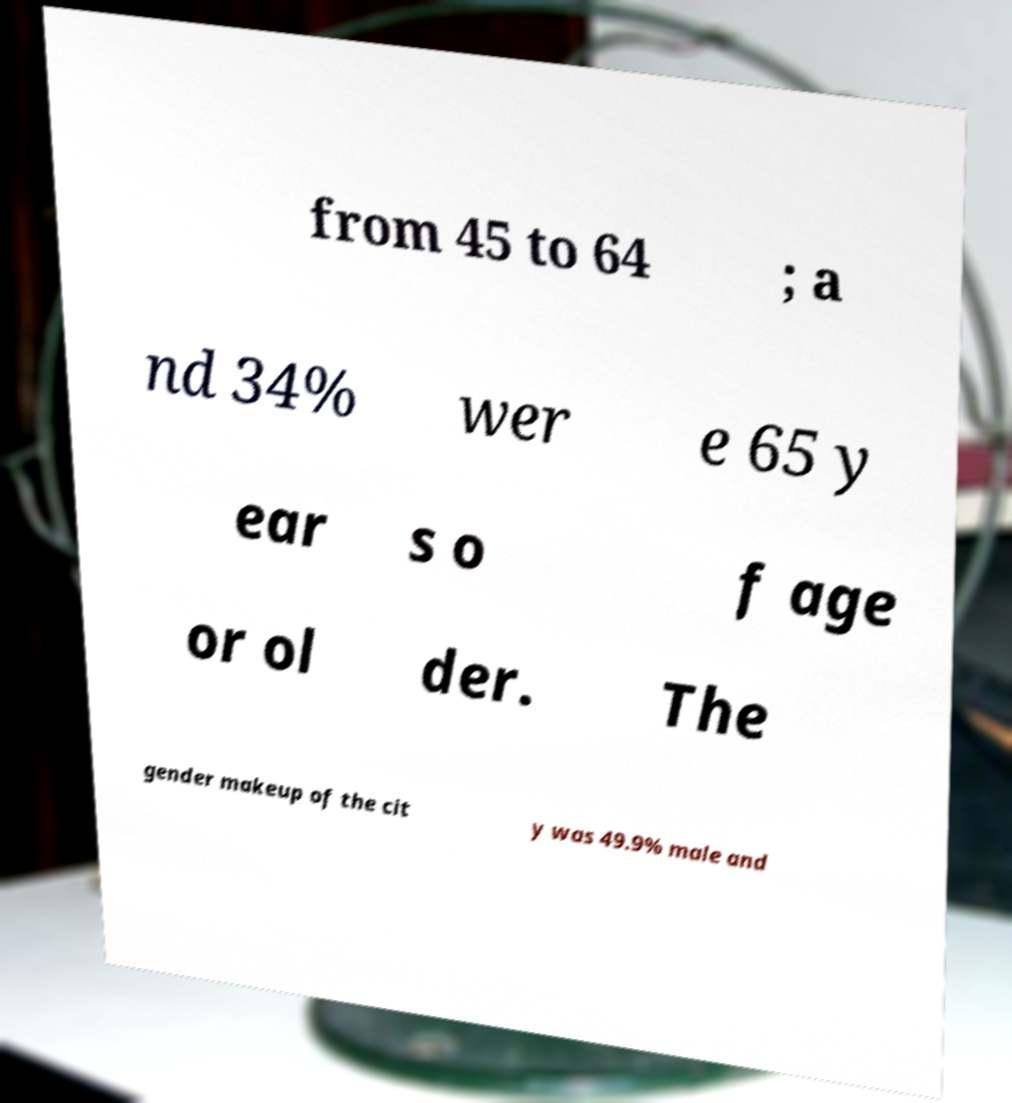I need the written content from this picture converted into text. Can you do that? from 45 to 64 ; a nd 34% wer e 65 y ear s o f age or ol der. The gender makeup of the cit y was 49.9% male and 